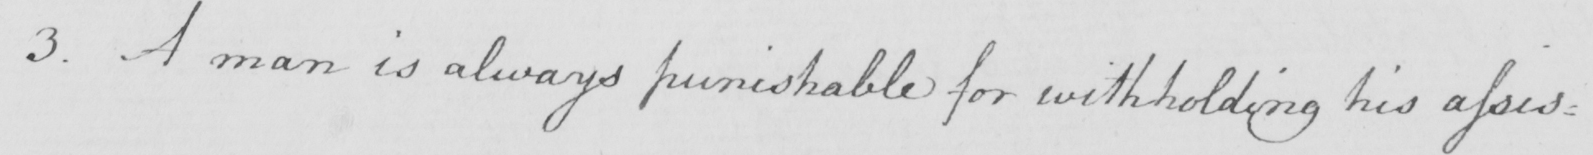Can you read and transcribe this handwriting? 3 . A man is always punishable for withholding his assis : 